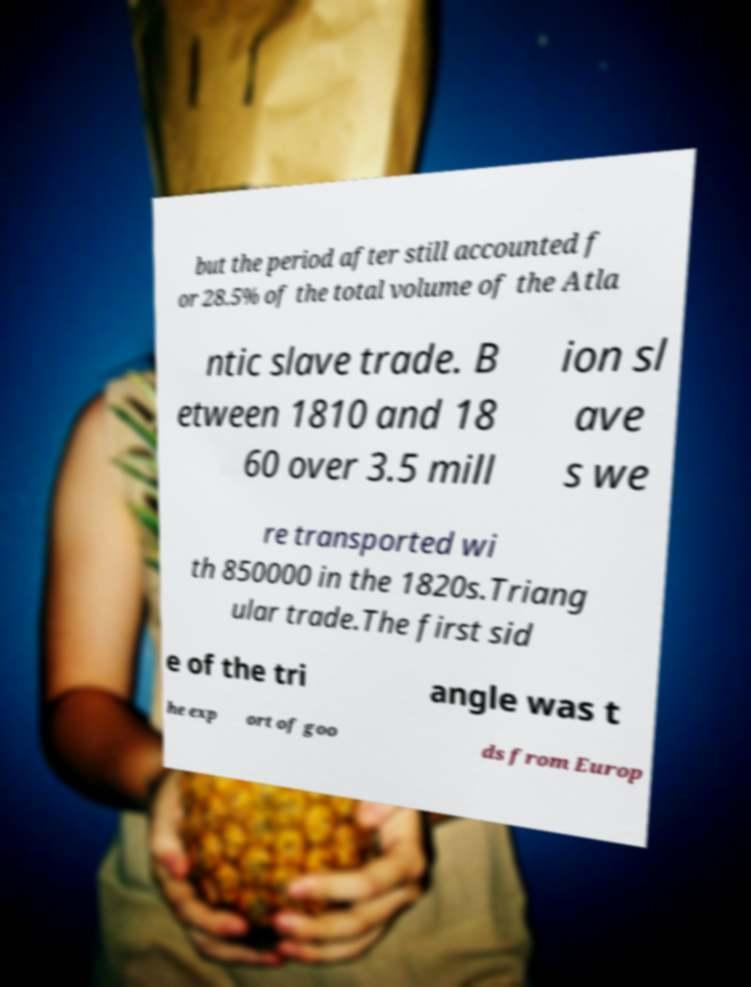What messages or text are displayed in this image? I need them in a readable, typed format. but the period after still accounted f or 28.5% of the total volume of the Atla ntic slave trade. B etween 1810 and 18 60 over 3.5 mill ion sl ave s we re transported wi th 850000 in the 1820s.Triang ular trade.The first sid e of the tri angle was t he exp ort of goo ds from Europ 